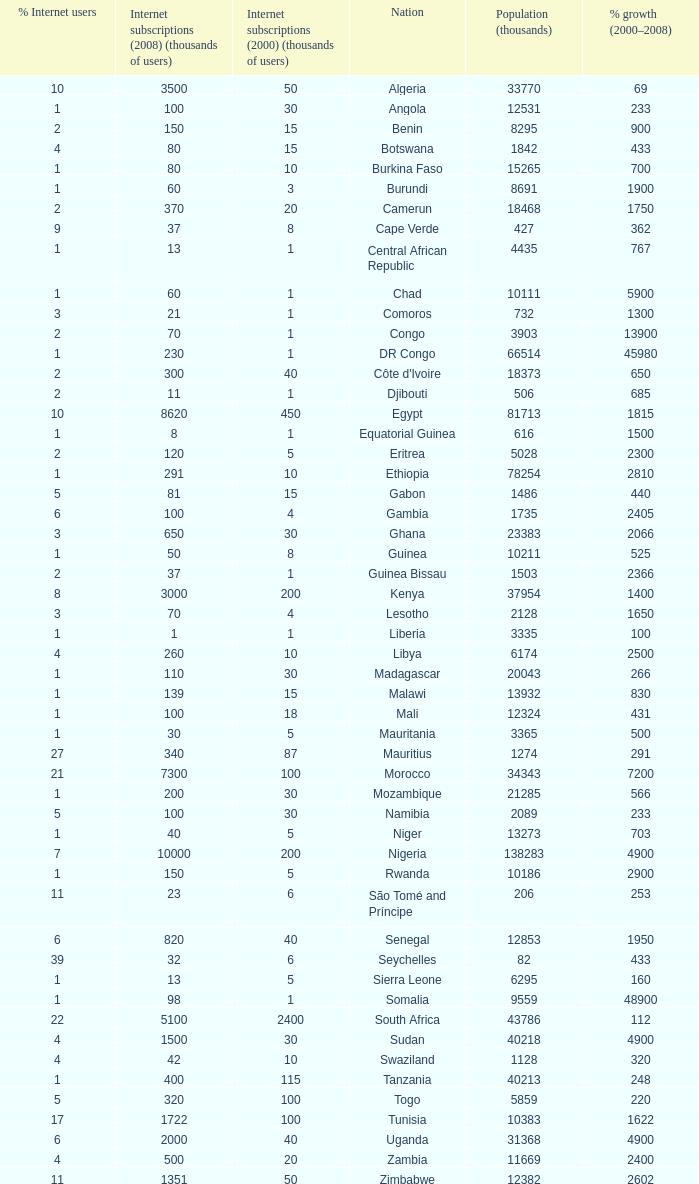What is the percentage of growth in 2000-2008 in ethiopia? 2810.0. 